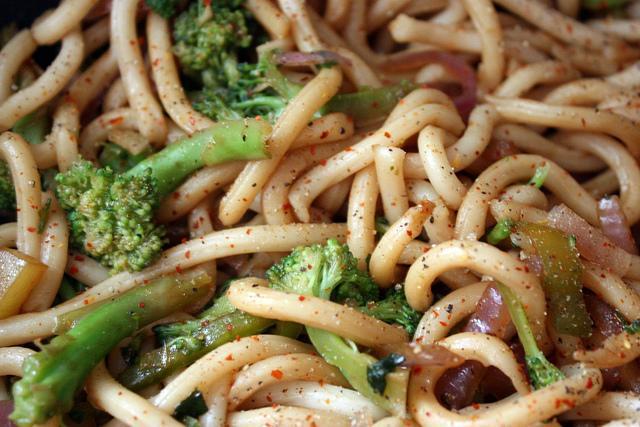How many broccolis are there?
Give a very brief answer. 4. How many motorcycles on the street?
Give a very brief answer. 0. 